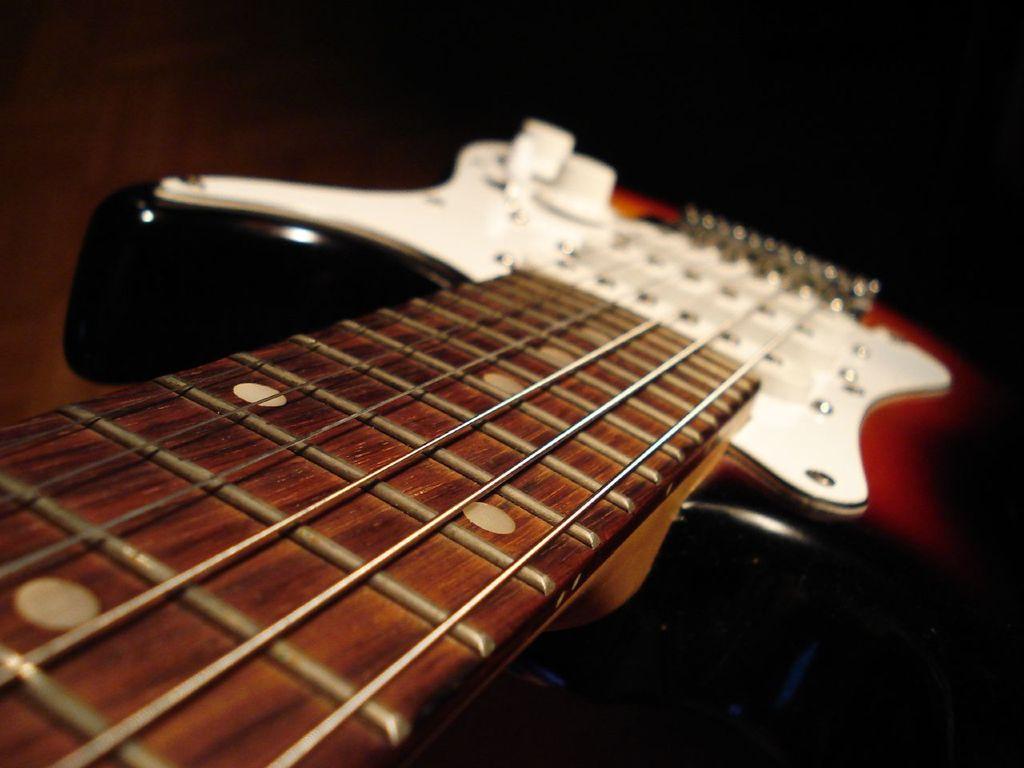Could you give a brief overview of what you see in this image? In this picture there is a guitar in a close up. 